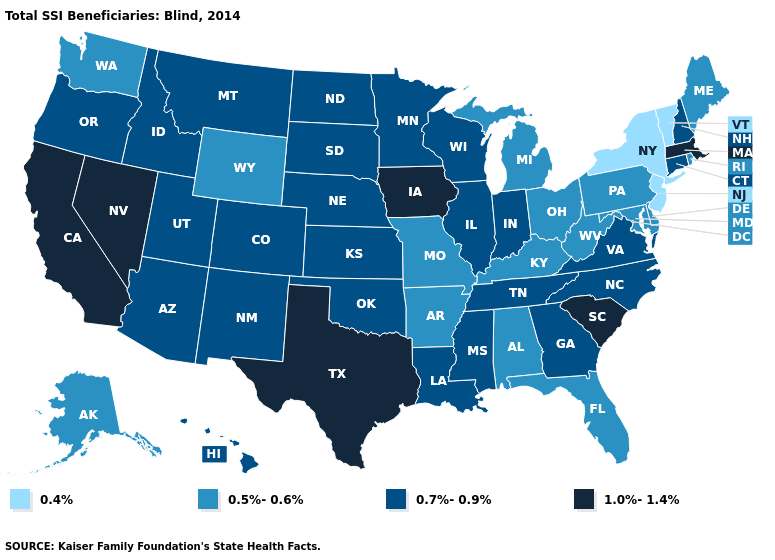What is the value of Rhode Island?
Keep it brief. 0.5%-0.6%. Name the states that have a value in the range 1.0%-1.4%?
Keep it brief. California, Iowa, Massachusetts, Nevada, South Carolina, Texas. Does New York have the lowest value in the USA?
Keep it brief. Yes. What is the value of Massachusetts?
Give a very brief answer. 1.0%-1.4%. What is the highest value in the West ?
Write a very short answer. 1.0%-1.4%. What is the highest value in the MidWest ?
Give a very brief answer. 1.0%-1.4%. Which states have the highest value in the USA?
Write a very short answer. California, Iowa, Massachusetts, Nevada, South Carolina, Texas. Does Arizona have the lowest value in the West?
Short answer required. No. Does Idaho have the lowest value in the West?
Answer briefly. No. Name the states that have a value in the range 0.7%-0.9%?
Quick response, please. Arizona, Colorado, Connecticut, Georgia, Hawaii, Idaho, Illinois, Indiana, Kansas, Louisiana, Minnesota, Mississippi, Montana, Nebraska, New Hampshire, New Mexico, North Carolina, North Dakota, Oklahoma, Oregon, South Dakota, Tennessee, Utah, Virginia, Wisconsin. What is the highest value in states that border Pennsylvania?
Answer briefly. 0.5%-0.6%. What is the value of Pennsylvania?
Short answer required. 0.5%-0.6%. What is the lowest value in the Northeast?
Give a very brief answer. 0.4%. Among the states that border Iowa , which have the highest value?
Keep it brief. Illinois, Minnesota, Nebraska, South Dakota, Wisconsin. Does West Virginia have a lower value than Arkansas?
Keep it brief. No. 